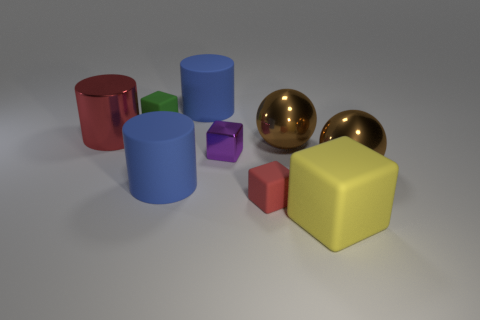How many things are small purple blocks or large red objects?
Make the answer very short. 2. The big brown metal thing that is behind the sphere to the right of the yellow block is what shape?
Provide a short and direct response. Sphere. What number of other things are there of the same material as the yellow thing
Provide a short and direct response. 4. Is the green object made of the same material as the big blue cylinder that is behind the big red metallic cylinder?
Ensure brevity in your answer.  Yes. How many things are big brown metal things that are behind the tiny purple thing or blue matte cylinders that are behind the green cube?
Keep it short and to the point. 2. What number of other objects are the same color as the large shiny cylinder?
Your answer should be very brief. 1. Is the number of small red matte objects that are behind the tiny red thing greater than the number of big shiny objects that are left of the red metallic thing?
Make the answer very short. No. What number of blocks are red matte things or green things?
Provide a short and direct response. 2. How many things are either big objects that are on the left side of the green rubber object or shiny cylinders?
Keep it short and to the point. 1. There is a large blue object that is to the right of the matte cylinder that is in front of the big blue thing behind the green rubber cube; what shape is it?
Provide a short and direct response. Cylinder. 